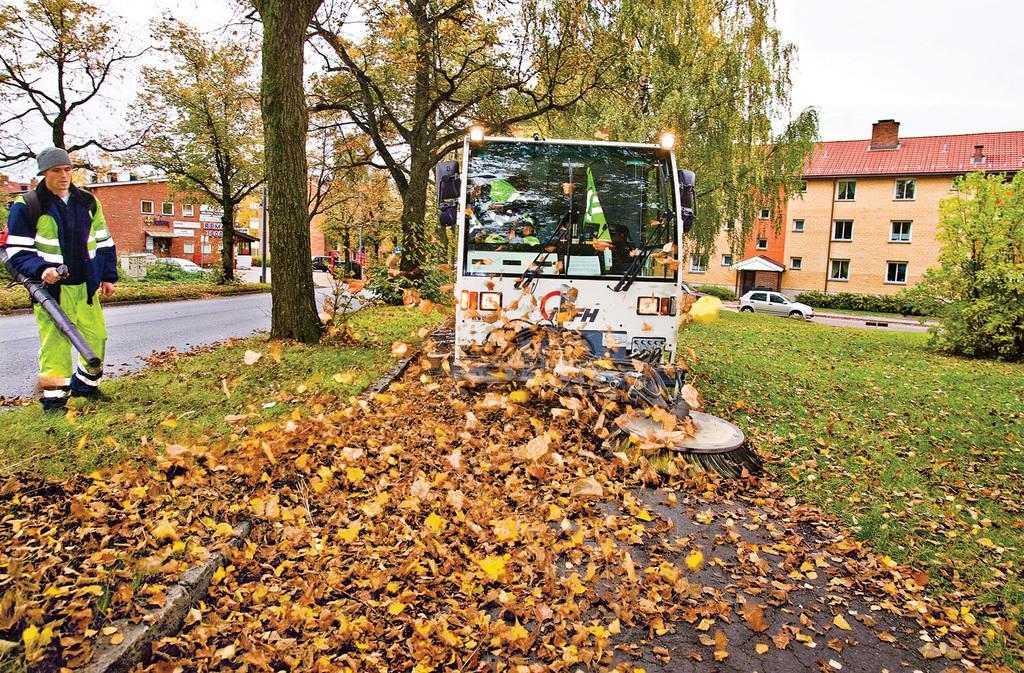In one or two sentences, can you explain what this image depicts? In this image we can see a person holding an object, there are leaves on the ground, there are few vehicles, buildings, windows, there are trees, plants, lights, also we can see the sky. 